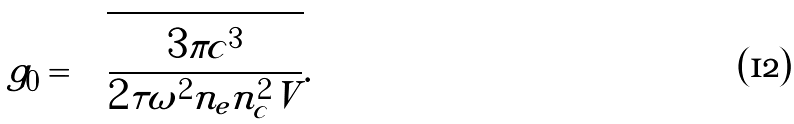<formula> <loc_0><loc_0><loc_500><loc_500>g _ { 0 } = \sqrt { \frac { 3 \pi c ^ { 3 } } { 2 \tau \omega ^ { 2 } n _ { e } n _ { c } ^ { 2 } V } } .</formula> 